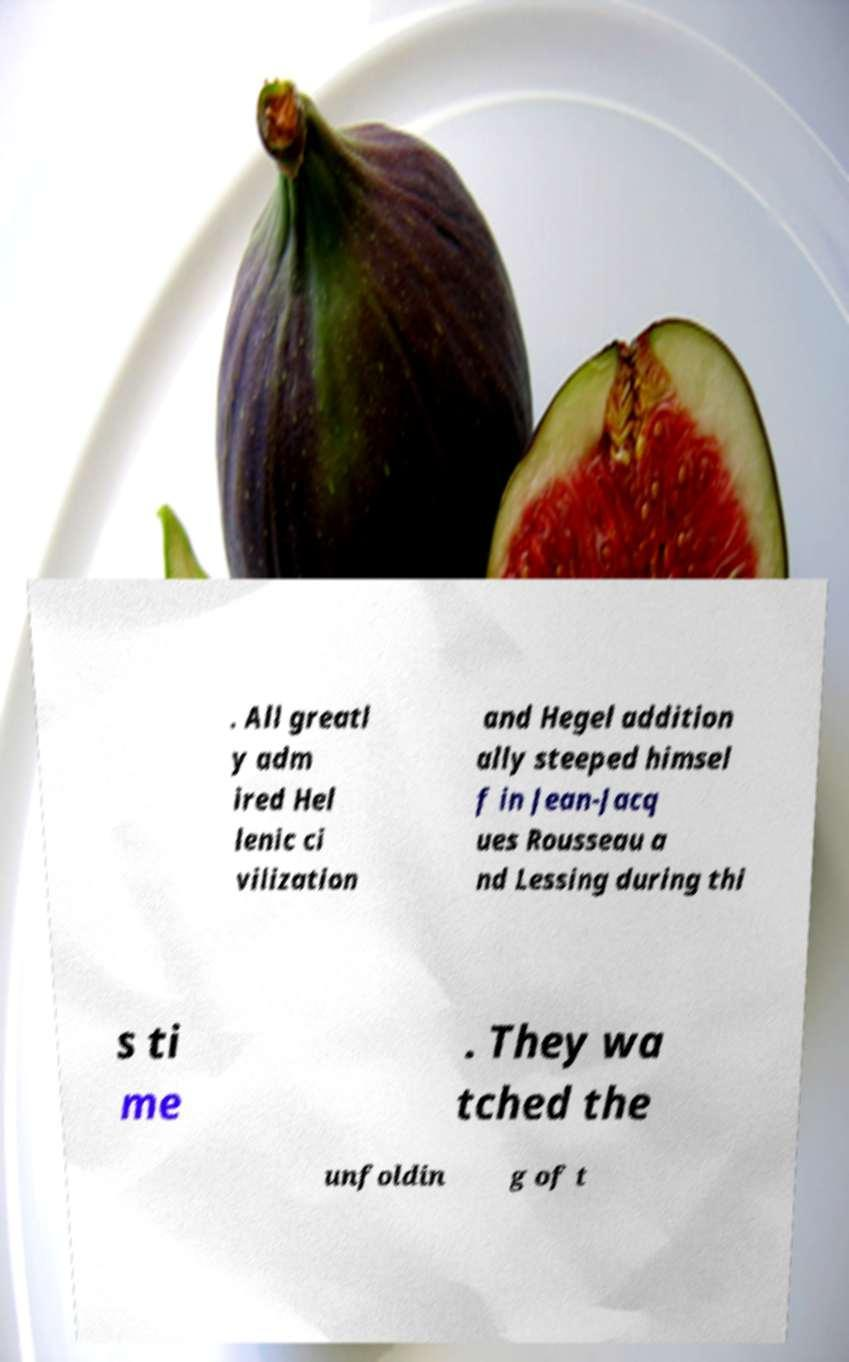Could you extract and type out the text from this image? . All greatl y adm ired Hel lenic ci vilization and Hegel addition ally steeped himsel f in Jean-Jacq ues Rousseau a nd Lessing during thi s ti me . They wa tched the unfoldin g of t 